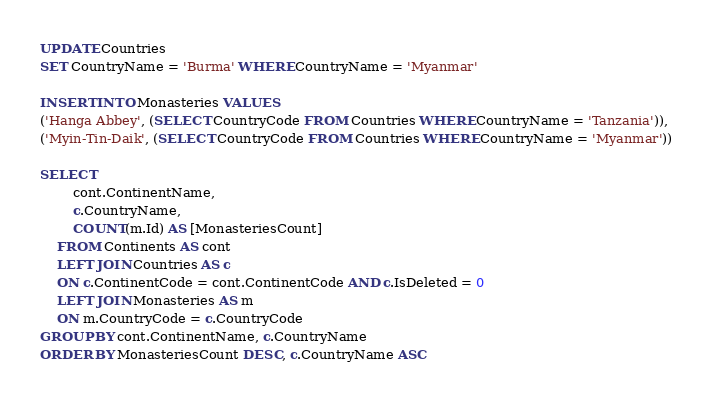Convert code to text. <code><loc_0><loc_0><loc_500><loc_500><_SQL_>UPDATE Countries
SET CountryName = 'Burma' WHERE CountryName = 'Myanmar'

INSERT INTO Monasteries VALUES 
('Hanga Abbey', (SELECT CountryCode FROM Countries WHERE CountryName = 'Tanzania')),
('Myin-Tin-Daik', (SELECT CountryCode FROM Countries WHERE CountryName = 'Myanmar'))

SELECT 
		cont.ContinentName,
		c.CountryName,
		COUNT(m.Id) AS [MonasteriesCount]
	FROM Continents AS cont
	LEFT JOIN Countries AS c
	ON c.ContinentCode = cont.ContinentCode AND c.IsDeleted = 0
	LEFT JOIN Monasteries AS m
	ON m.CountryCode = c.CountryCode
GROUP BY cont.ContinentName, c.CountryName
ORDER BY MonasteriesCount DESC, c.CountryName ASC</code> 